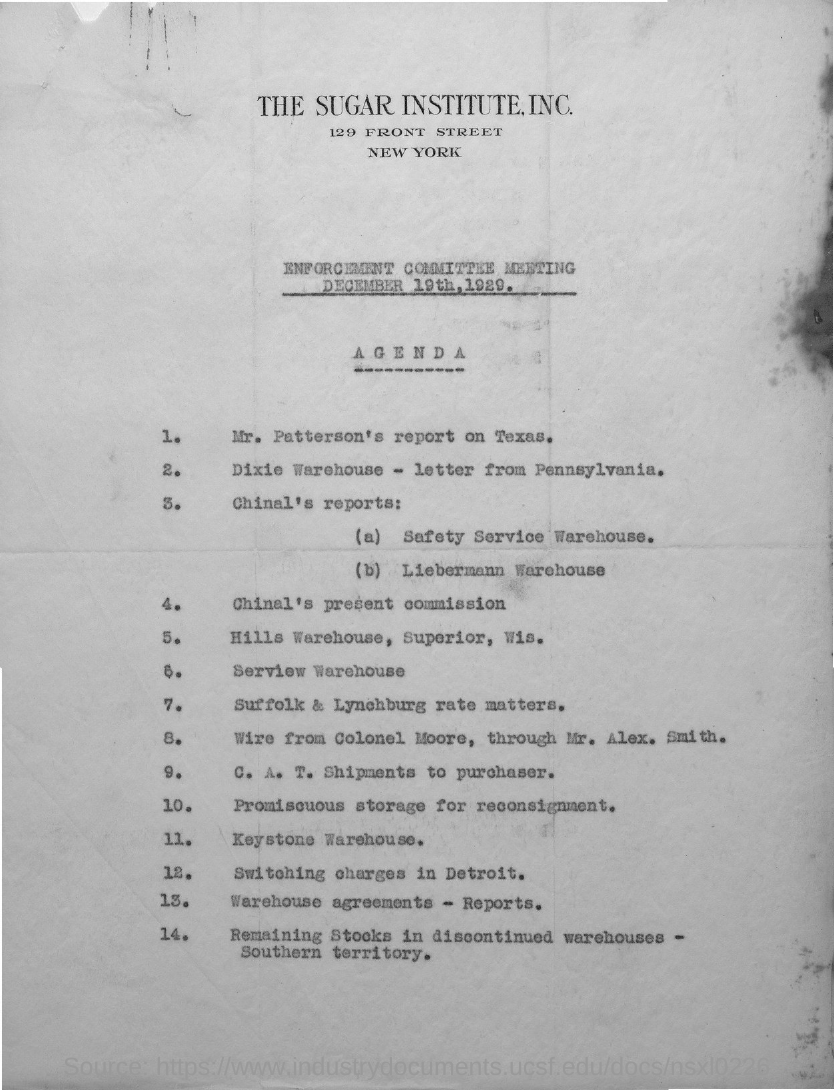Highlight a few significant elements in this photo. The name of the organization listed on the letterhead is The Sugar Institute, Inc. 